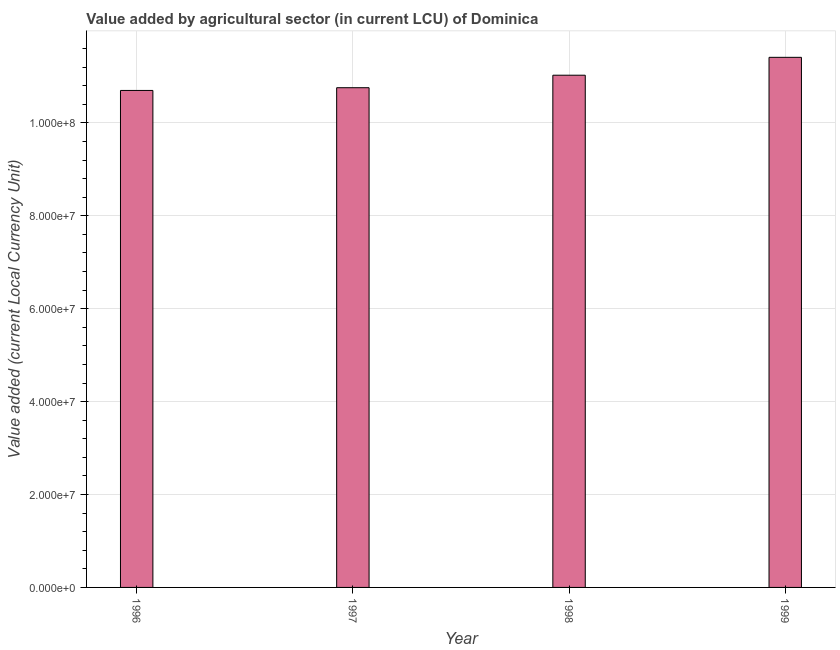Does the graph contain grids?
Offer a very short reply. Yes. What is the title of the graph?
Your response must be concise. Value added by agricultural sector (in current LCU) of Dominica. What is the label or title of the X-axis?
Give a very brief answer. Year. What is the label or title of the Y-axis?
Your answer should be very brief. Value added (current Local Currency Unit). What is the value added by agriculture sector in 1996?
Offer a very short reply. 1.07e+08. Across all years, what is the maximum value added by agriculture sector?
Your answer should be compact. 1.14e+08. Across all years, what is the minimum value added by agriculture sector?
Your response must be concise. 1.07e+08. In which year was the value added by agriculture sector minimum?
Ensure brevity in your answer.  1996. What is the sum of the value added by agriculture sector?
Make the answer very short. 4.39e+08. What is the difference between the value added by agriculture sector in 1996 and 1999?
Make the answer very short. -7.13e+06. What is the average value added by agriculture sector per year?
Keep it short and to the point. 1.10e+08. What is the median value added by agriculture sector?
Offer a very short reply. 1.09e+08. In how many years, is the value added by agriculture sector greater than 92000000 LCU?
Make the answer very short. 4. Do a majority of the years between 1999 and 1997 (inclusive) have value added by agriculture sector greater than 48000000 LCU?
Offer a very short reply. Yes. What is the ratio of the value added by agriculture sector in 1996 to that in 1999?
Give a very brief answer. 0.94. Is the value added by agriculture sector in 1996 less than that in 1998?
Ensure brevity in your answer.  Yes. Is the difference between the value added by agriculture sector in 1996 and 1998 greater than the difference between any two years?
Offer a terse response. No. What is the difference between the highest and the second highest value added by agriculture sector?
Make the answer very short. 3.85e+06. What is the difference between the highest and the lowest value added by agriculture sector?
Your answer should be very brief. 7.13e+06. How many bars are there?
Your answer should be compact. 4. How many years are there in the graph?
Provide a short and direct response. 4. What is the difference between two consecutive major ticks on the Y-axis?
Offer a terse response. 2.00e+07. Are the values on the major ticks of Y-axis written in scientific E-notation?
Offer a very short reply. Yes. What is the Value added (current Local Currency Unit) of 1996?
Your response must be concise. 1.07e+08. What is the Value added (current Local Currency Unit) in 1997?
Make the answer very short. 1.08e+08. What is the Value added (current Local Currency Unit) in 1998?
Keep it short and to the point. 1.10e+08. What is the Value added (current Local Currency Unit) of 1999?
Provide a succinct answer. 1.14e+08. What is the difference between the Value added (current Local Currency Unit) in 1996 and 1997?
Provide a succinct answer. -5.90e+05. What is the difference between the Value added (current Local Currency Unit) in 1996 and 1998?
Your response must be concise. -3.28e+06. What is the difference between the Value added (current Local Currency Unit) in 1996 and 1999?
Keep it short and to the point. -7.13e+06. What is the difference between the Value added (current Local Currency Unit) in 1997 and 1998?
Offer a very short reply. -2.69e+06. What is the difference between the Value added (current Local Currency Unit) in 1997 and 1999?
Your response must be concise. -6.54e+06. What is the difference between the Value added (current Local Currency Unit) in 1998 and 1999?
Provide a succinct answer. -3.85e+06. What is the ratio of the Value added (current Local Currency Unit) in 1996 to that in 1998?
Give a very brief answer. 0.97. What is the ratio of the Value added (current Local Currency Unit) in 1996 to that in 1999?
Your answer should be compact. 0.94. What is the ratio of the Value added (current Local Currency Unit) in 1997 to that in 1999?
Your answer should be compact. 0.94. What is the ratio of the Value added (current Local Currency Unit) in 1998 to that in 1999?
Your answer should be very brief. 0.97. 